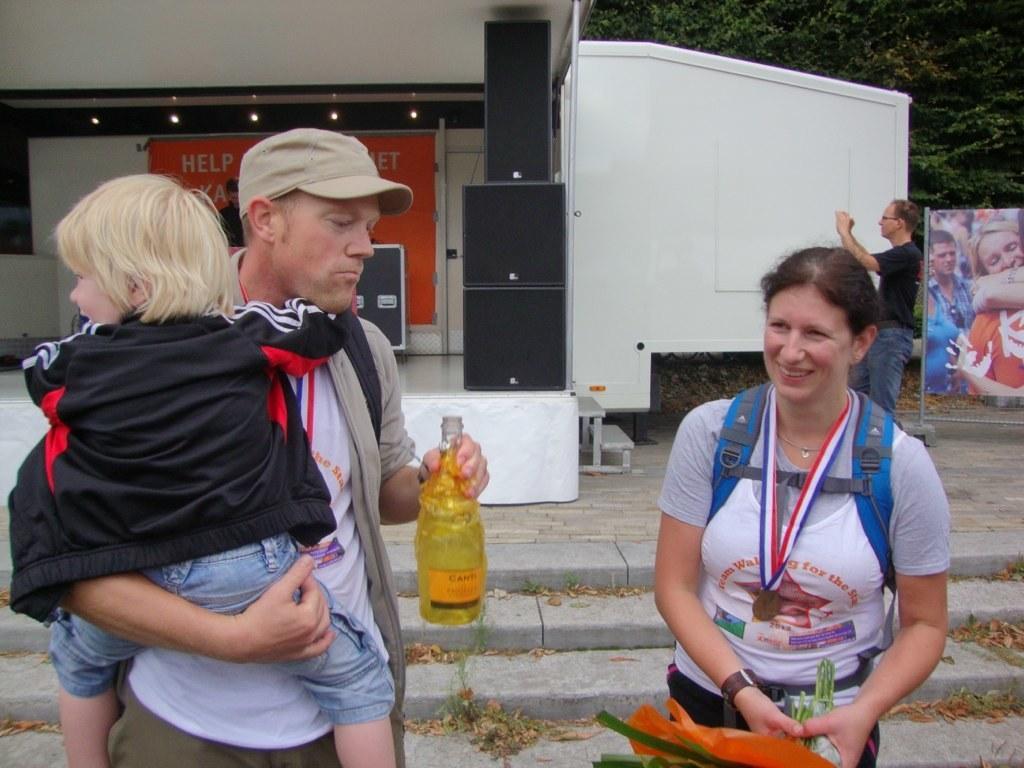Describe this image in one or two sentences. In the image there are two people standing in the front and the first person is holding a kid with his hand and a bottle in his other hand, behind them there are many speakers and on the right side another person is making some arrangements, beside him there is a poster and in the background there are few trees. 